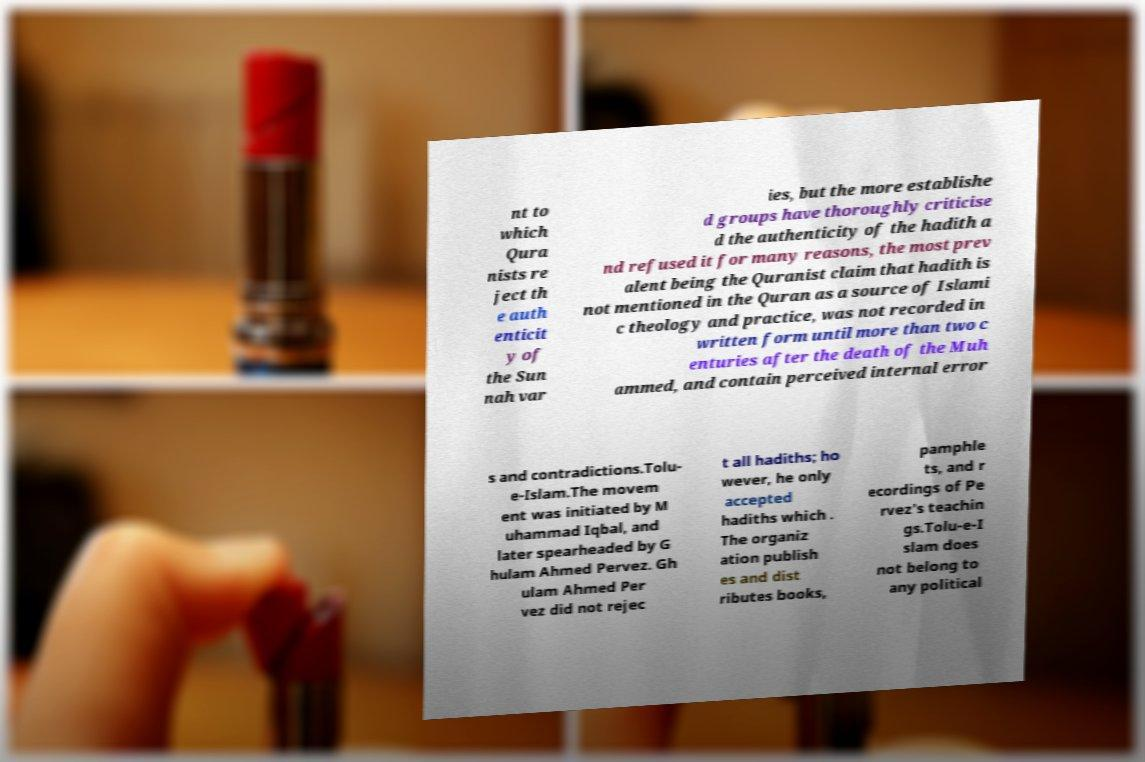Please identify and transcribe the text found in this image. nt to which Qura nists re ject th e auth enticit y of the Sun nah var ies, but the more establishe d groups have thoroughly criticise d the authenticity of the hadith a nd refused it for many reasons, the most prev alent being the Quranist claim that hadith is not mentioned in the Quran as a source of Islami c theology and practice, was not recorded in written form until more than two c enturies after the death of the Muh ammed, and contain perceived internal error s and contradictions.Tolu- e-Islam.The movem ent was initiated by M uhammad Iqbal, and later spearheaded by G hulam Ahmed Pervez. Gh ulam Ahmed Per vez did not rejec t all hadiths; ho wever, he only accepted hadiths which . The organiz ation publish es and dist ributes books, pamphle ts, and r ecordings of Pe rvez's teachin gs.Tolu-e-I slam does not belong to any political 